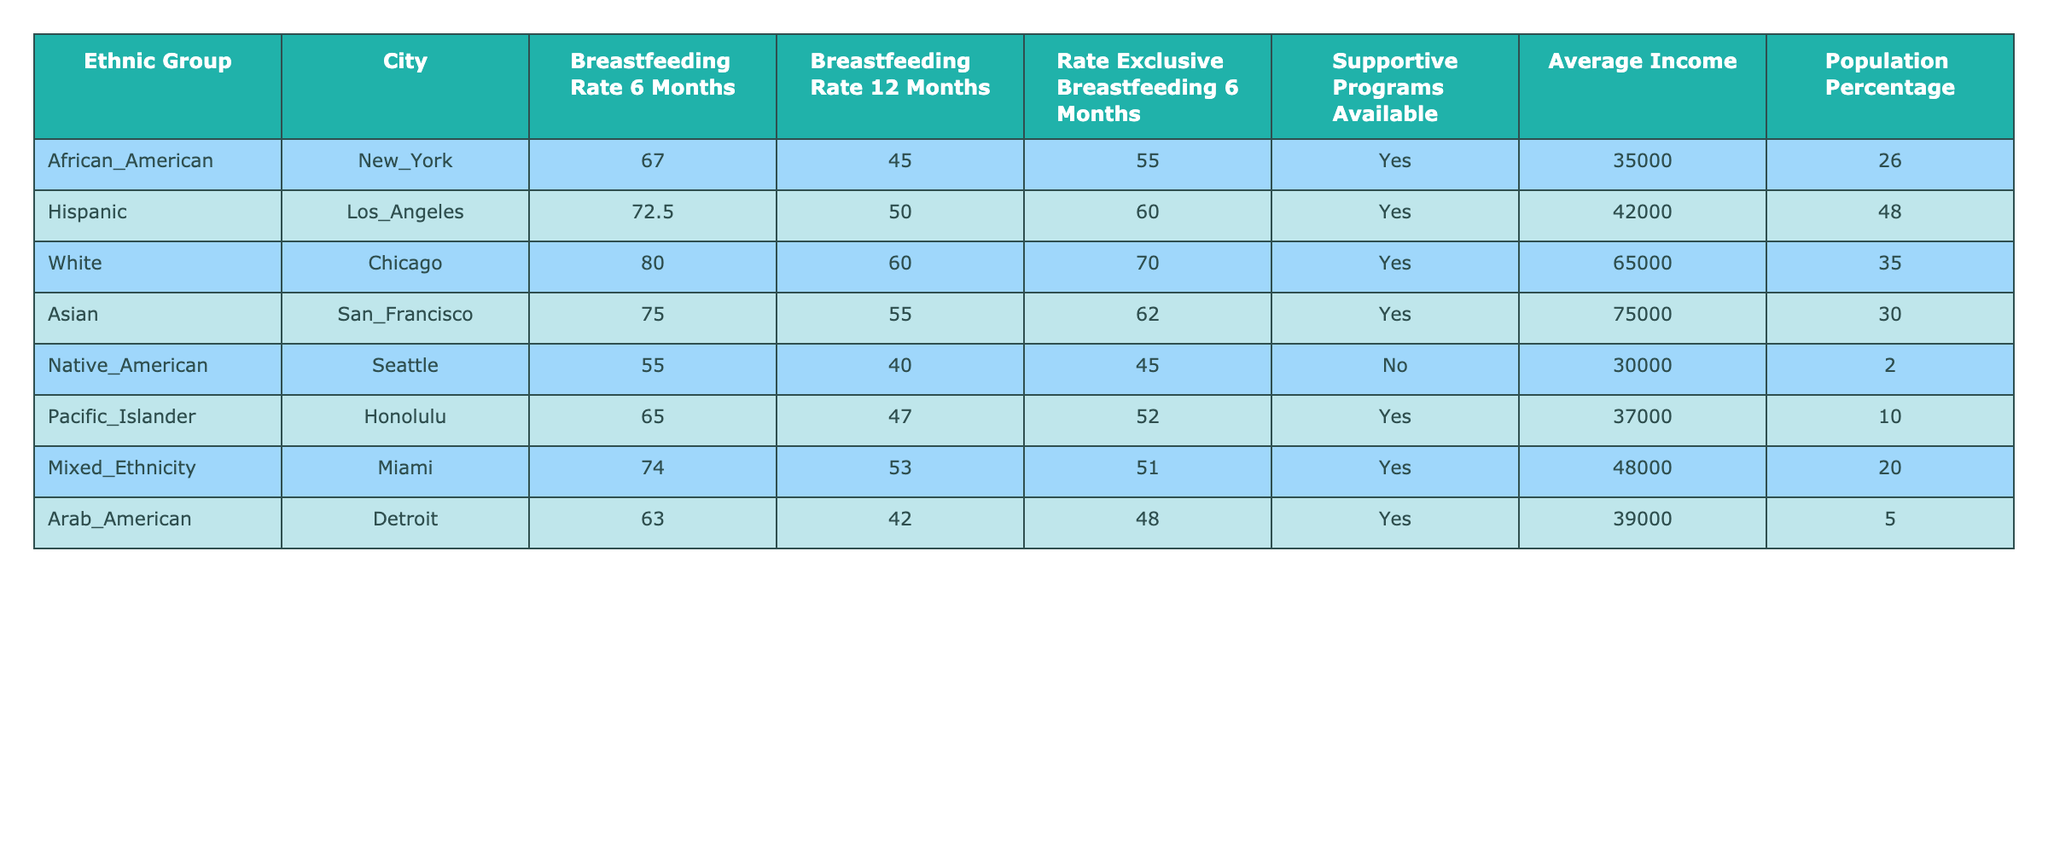What is the breastfeeding rate at 6 months for Hispanic ethnic groups in Los Angeles? The table shows that the breastfeeding rate at 6 months for Hispanic ethnic groups in Los Angeles is listed under the "Breastfeeding Rate 6 Months" column. Referring to that column for the Hispanic row, the value is 72.5.
Answer: 72.5 What is the average breastfeeding rate at 12 months among the ethnic groups listed? To find the average breastfeeding rate at 12 months, we first add the rates: (45.0 + 50.0 + 60.0 + 55.0 + 40.0 + 47.0 + 53.0 + 42.0) = 392. There are 8 ethnic groups, so we divide 392 by 8 to obtain the average: 392/8 = 49.0.
Answer: 49.0 Are there supportive programs available for the Native American community in Seattle? The row corresponding to the Native American community shows "No" under the "Supportive Programs Available" column. Therefore, the answer is no.
Answer: No Which ethnic group has the highest breastfeeding rate at 6 months and what is that rate? By looking at the "Breastfeeding Rate 6 Months" column, the maximum value is 80.0, which corresponds to the White ethnic group in Chicago. Thus, the White ethnic group has the highest breastfeeding rate at 6 months.
Answer: 80.0 What is the difference in the breastfeeding rate at 12 months between the African American and the Asian ethnic groups? From the table, the breastfeeding rate at 12 months for African Americans is 45.0, and for Asians, it is 55.0. To find the difference, we subtract: 55.0 - 45.0 = 10.0.
Answer: 10.0 Which city has the lowest average income among the listed ethnic groups, and what is that income? Looking at the "Average Income" column, the lowest value is 30,000, which corresponds to the Native American group in Seattle. Therefore, Seattle has the lowest average income.
Answer: 30,000 Is the exclusive breastfeeding rate at 6 months higher for the Asian group than for the Pacific Islander group? The exclusive breastfeeding rate at 6 months for the Asian group is 62.0, while for the Pacific Islander group, it is 52.0. Since 62.0 is greater than 52.0, the answer is yes.
Answer: Yes What is the overall population percentage of the Mixed Ethnicity group in Miami compared to the African American group in New York? The population percentage for the Mixed Ethnicity group in Miami is 20.0, while for the African American group in New York, it is 26.0. Comparing these, 26.0 - 20.0 = 6.0 percent more for African Americans.
Answer: 6.0 How many ethnic groups have a breastfeeding rate at 12 months below 50%? Reviewing the "Breastfeeding Rate 12 Months" column, we find that African American (45.0) and Native American (40.0) have rates below 50%. Thus, there are 2 ethnic groups in this category.
Answer: 2 What is the combined breastfeeding rate at 6 months for the Hispanic and Mixed Ethnicity groups? The breastfeeding rate at 6 months for the Hispanic group is 72.5 and for Mixed Ethnicity, it is 74.0. Adding these values gives us 72.5 + 74.0 = 146.5.
Answer: 146.5 